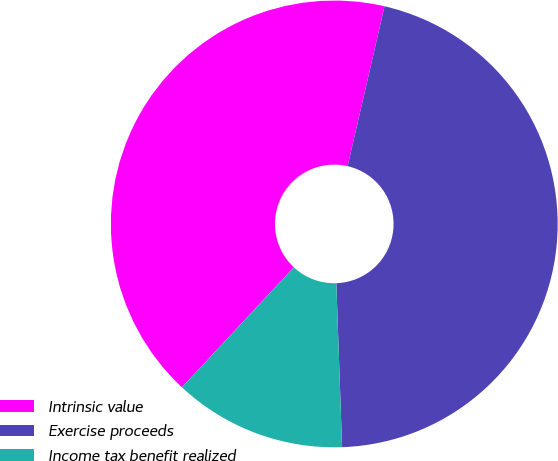Convert chart. <chart><loc_0><loc_0><loc_500><loc_500><pie_chart><fcel>Intrinsic value<fcel>Exercise proceeds<fcel>Income tax benefit realized<nl><fcel>41.67%<fcel>45.83%<fcel>12.5%<nl></chart> 